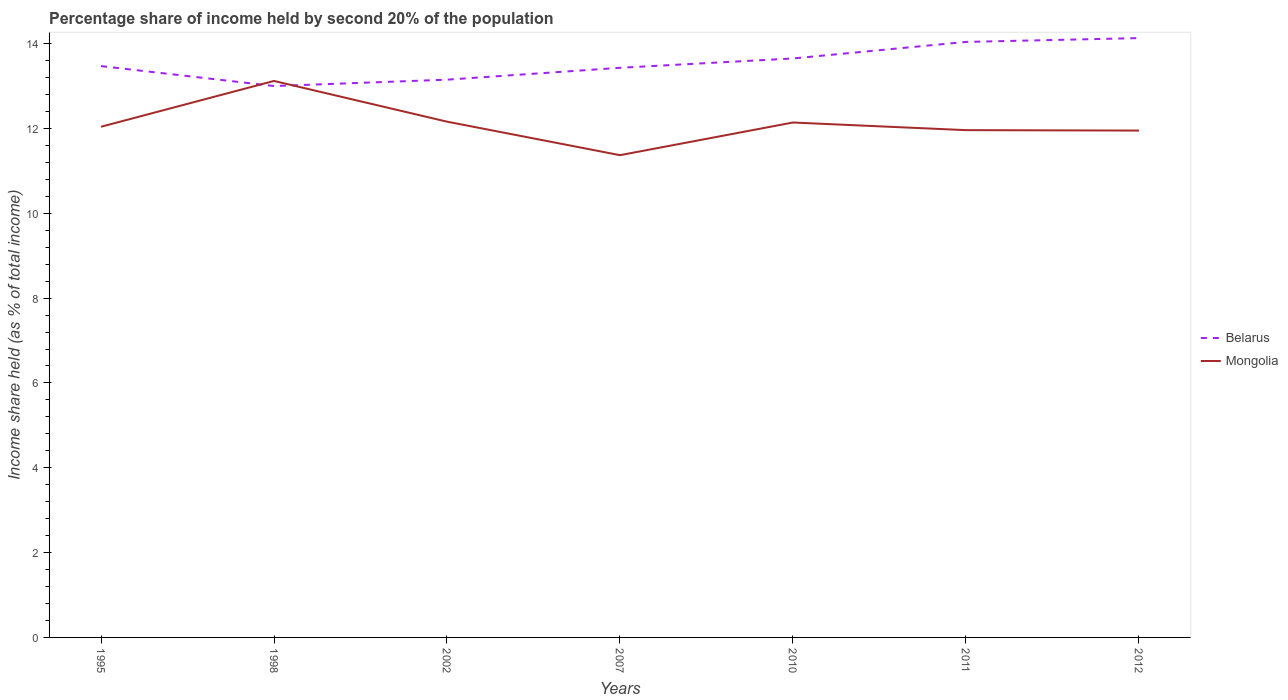Is the number of lines equal to the number of legend labels?
Provide a succinct answer. Yes. Across all years, what is the maximum share of income held by second 20% of the population in Mongolia?
Offer a very short reply. 11.37. What is the total share of income held by second 20% of the population in Belarus in the graph?
Offer a very short reply. -0.15. What is the difference between the highest and the second highest share of income held by second 20% of the population in Mongolia?
Give a very brief answer. 1.75. What is the difference between the highest and the lowest share of income held by second 20% of the population in Mongolia?
Offer a terse response. 3. Is the share of income held by second 20% of the population in Mongolia strictly greater than the share of income held by second 20% of the population in Belarus over the years?
Provide a succinct answer. No. How many years are there in the graph?
Your answer should be very brief. 7. Does the graph contain any zero values?
Your response must be concise. No. Does the graph contain grids?
Make the answer very short. No. What is the title of the graph?
Ensure brevity in your answer.  Percentage share of income held by second 20% of the population. Does "Russian Federation" appear as one of the legend labels in the graph?
Give a very brief answer. No. What is the label or title of the Y-axis?
Offer a terse response. Income share held (as % of total income). What is the Income share held (as % of total income) in Belarus in 1995?
Offer a very short reply. 13.47. What is the Income share held (as % of total income) in Mongolia in 1995?
Make the answer very short. 12.04. What is the Income share held (as % of total income) in Mongolia in 1998?
Keep it short and to the point. 13.12. What is the Income share held (as % of total income) of Belarus in 2002?
Your answer should be compact. 13.15. What is the Income share held (as % of total income) in Mongolia in 2002?
Offer a terse response. 12.16. What is the Income share held (as % of total income) in Belarus in 2007?
Your answer should be compact. 13.43. What is the Income share held (as % of total income) of Mongolia in 2007?
Your response must be concise. 11.37. What is the Income share held (as % of total income) of Belarus in 2010?
Offer a terse response. 13.65. What is the Income share held (as % of total income) in Mongolia in 2010?
Give a very brief answer. 12.14. What is the Income share held (as % of total income) in Belarus in 2011?
Your answer should be compact. 14.04. What is the Income share held (as % of total income) of Mongolia in 2011?
Your answer should be very brief. 11.96. What is the Income share held (as % of total income) in Belarus in 2012?
Your answer should be very brief. 14.13. What is the Income share held (as % of total income) of Mongolia in 2012?
Your response must be concise. 11.95. Across all years, what is the maximum Income share held (as % of total income) in Belarus?
Give a very brief answer. 14.13. Across all years, what is the maximum Income share held (as % of total income) of Mongolia?
Offer a very short reply. 13.12. Across all years, what is the minimum Income share held (as % of total income) in Belarus?
Keep it short and to the point. 13. Across all years, what is the minimum Income share held (as % of total income) in Mongolia?
Your answer should be compact. 11.37. What is the total Income share held (as % of total income) in Belarus in the graph?
Offer a very short reply. 94.87. What is the total Income share held (as % of total income) in Mongolia in the graph?
Give a very brief answer. 84.74. What is the difference between the Income share held (as % of total income) of Belarus in 1995 and that in 1998?
Make the answer very short. 0.47. What is the difference between the Income share held (as % of total income) of Mongolia in 1995 and that in 1998?
Keep it short and to the point. -1.08. What is the difference between the Income share held (as % of total income) in Belarus in 1995 and that in 2002?
Your response must be concise. 0.32. What is the difference between the Income share held (as % of total income) in Mongolia in 1995 and that in 2002?
Ensure brevity in your answer.  -0.12. What is the difference between the Income share held (as % of total income) of Mongolia in 1995 and that in 2007?
Give a very brief answer. 0.67. What is the difference between the Income share held (as % of total income) in Belarus in 1995 and that in 2010?
Your answer should be very brief. -0.18. What is the difference between the Income share held (as % of total income) in Mongolia in 1995 and that in 2010?
Offer a terse response. -0.1. What is the difference between the Income share held (as % of total income) in Belarus in 1995 and that in 2011?
Offer a very short reply. -0.57. What is the difference between the Income share held (as % of total income) in Belarus in 1995 and that in 2012?
Ensure brevity in your answer.  -0.66. What is the difference between the Income share held (as % of total income) in Mongolia in 1995 and that in 2012?
Your answer should be compact. 0.09. What is the difference between the Income share held (as % of total income) in Belarus in 1998 and that in 2002?
Keep it short and to the point. -0.15. What is the difference between the Income share held (as % of total income) in Belarus in 1998 and that in 2007?
Provide a succinct answer. -0.43. What is the difference between the Income share held (as % of total income) in Belarus in 1998 and that in 2010?
Offer a terse response. -0.65. What is the difference between the Income share held (as % of total income) in Belarus in 1998 and that in 2011?
Your response must be concise. -1.04. What is the difference between the Income share held (as % of total income) in Mongolia in 1998 and that in 2011?
Provide a succinct answer. 1.16. What is the difference between the Income share held (as % of total income) in Belarus in 1998 and that in 2012?
Your response must be concise. -1.13. What is the difference between the Income share held (as % of total income) of Mongolia in 1998 and that in 2012?
Keep it short and to the point. 1.17. What is the difference between the Income share held (as % of total income) of Belarus in 2002 and that in 2007?
Ensure brevity in your answer.  -0.28. What is the difference between the Income share held (as % of total income) of Mongolia in 2002 and that in 2007?
Keep it short and to the point. 0.79. What is the difference between the Income share held (as % of total income) of Belarus in 2002 and that in 2010?
Offer a very short reply. -0.5. What is the difference between the Income share held (as % of total income) in Belarus in 2002 and that in 2011?
Provide a succinct answer. -0.89. What is the difference between the Income share held (as % of total income) of Belarus in 2002 and that in 2012?
Your answer should be compact. -0.98. What is the difference between the Income share held (as % of total income) in Mongolia in 2002 and that in 2012?
Give a very brief answer. 0.21. What is the difference between the Income share held (as % of total income) in Belarus in 2007 and that in 2010?
Offer a very short reply. -0.22. What is the difference between the Income share held (as % of total income) of Mongolia in 2007 and that in 2010?
Your answer should be compact. -0.77. What is the difference between the Income share held (as % of total income) in Belarus in 2007 and that in 2011?
Your response must be concise. -0.61. What is the difference between the Income share held (as % of total income) in Mongolia in 2007 and that in 2011?
Offer a terse response. -0.59. What is the difference between the Income share held (as % of total income) of Mongolia in 2007 and that in 2012?
Your response must be concise. -0.58. What is the difference between the Income share held (as % of total income) of Belarus in 2010 and that in 2011?
Your response must be concise. -0.39. What is the difference between the Income share held (as % of total income) of Mongolia in 2010 and that in 2011?
Keep it short and to the point. 0.18. What is the difference between the Income share held (as % of total income) of Belarus in 2010 and that in 2012?
Provide a short and direct response. -0.48. What is the difference between the Income share held (as % of total income) in Mongolia in 2010 and that in 2012?
Offer a very short reply. 0.19. What is the difference between the Income share held (as % of total income) in Belarus in 2011 and that in 2012?
Your answer should be compact. -0.09. What is the difference between the Income share held (as % of total income) of Mongolia in 2011 and that in 2012?
Your answer should be compact. 0.01. What is the difference between the Income share held (as % of total income) in Belarus in 1995 and the Income share held (as % of total income) in Mongolia in 1998?
Make the answer very short. 0.35. What is the difference between the Income share held (as % of total income) in Belarus in 1995 and the Income share held (as % of total income) in Mongolia in 2002?
Your answer should be very brief. 1.31. What is the difference between the Income share held (as % of total income) in Belarus in 1995 and the Income share held (as % of total income) in Mongolia in 2007?
Ensure brevity in your answer.  2.1. What is the difference between the Income share held (as % of total income) of Belarus in 1995 and the Income share held (as % of total income) of Mongolia in 2010?
Offer a very short reply. 1.33. What is the difference between the Income share held (as % of total income) in Belarus in 1995 and the Income share held (as % of total income) in Mongolia in 2011?
Your response must be concise. 1.51. What is the difference between the Income share held (as % of total income) of Belarus in 1995 and the Income share held (as % of total income) of Mongolia in 2012?
Ensure brevity in your answer.  1.52. What is the difference between the Income share held (as % of total income) of Belarus in 1998 and the Income share held (as % of total income) of Mongolia in 2002?
Offer a terse response. 0.84. What is the difference between the Income share held (as % of total income) of Belarus in 1998 and the Income share held (as % of total income) of Mongolia in 2007?
Provide a short and direct response. 1.63. What is the difference between the Income share held (as % of total income) in Belarus in 1998 and the Income share held (as % of total income) in Mongolia in 2010?
Provide a short and direct response. 0.86. What is the difference between the Income share held (as % of total income) of Belarus in 1998 and the Income share held (as % of total income) of Mongolia in 2012?
Your answer should be very brief. 1.05. What is the difference between the Income share held (as % of total income) of Belarus in 2002 and the Income share held (as % of total income) of Mongolia in 2007?
Make the answer very short. 1.78. What is the difference between the Income share held (as % of total income) of Belarus in 2002 and the Income share held (as % of total income) of Mongolia in 2011?
Keep it short and to the point. 1.19. What is the difference between the Income share held (as % of total income) of Belarus in 2007 and the Income share held (as % of total income) of Mongolia in 2010?
Give a very brief answer. 1.29. What is the difference between the Income share held (as % of total income) of Belarus in 2007 and the Income share held (as % of total income) of Mongolia in 2011?
Provide a short and direct response. 1.47. What is the difference between the Income share held (as % of total income) of Belarus in 2007 and the Income share held (as % of total income) of Mongolia in 2012?
Give a very brief answer. 1.48. What is the difference between the Income share held (as % of total income) in Belarus in 2010 and the Income share held (as % of total income) in Mongolia in 2011?
Give a very brief answer. 1.69. What is the difference between the Income share held (as % of total income) in Belarus in 2010 and the Income share held (as % of total income) in Mongolia in 2012?
Make the answer very short. 1.7. What is the difference between the Income share held (as % of total income) of Belarus in 2011 and the Income share held (as % of total income) of Mongolia in 2012?
Provide a short and direct response. 2.09. What is the average Income share held (as % of total income) of Belarus per year?
Provide a short and direct response. 13.55. What is the average Income share held (as % of total income) of Mongolia per year?
Ensure brevity in your answer.  12.11. In the year 1995, what is the difference between the Income share held (as % of total income) of Belarus and Income share held (as % of total income) of Mongolia?
Keep it short and to the point. 1.43. In the year 1998, what is the difference between the Income share held (as % of total income) of Belarus and Income share held (as % of total income) of Mongolia?
Offer a terse response. -0.12. In the year 2002, what is the difference between the Income share held (as % of total income) of Belarus and Income share held (as % of total income) of Mongolia?
Your response must be concise. 0.99. In the year 2007, what is the difference between the Income share held (as % of total income) of Belarus and Income share held (as % of total income) of Mongolia?
Ensure brevity in your answer.  2.06. In the year 2010, what is the difference between the Income share held (as % of total income) of Belarus and Income share held (as % of total income) of Mongolia?
Your response must be concise. 1.51. In the year 2011, what is the difference between the Income share held (as % of total income) of Belarus and Income share held (as % of total income) of Mongolia?
Your answer should be very brief. 2.08. In the year 2012, what is the difference between the Income share held (as % of total income) of Belarus and Income share held (as % of total income) of Mongolia?
Offer a terse response. 2.18. What is the ratio of the Income share held (as % of total income) in Belarus in 1995 to that in 1998?
Offer a terse response. 1.04. What is the ratio of the Income share held (as % of total income) of Mongolia in 1995 to that in 1998?
Ensure brevity in your answer.  0.92. What is the ratio of the Income share held (as % of total income) of Belarus in 1995 to that in 2002?
Keep it short and to the point. 1.02. What is the ratio of the Income share held (as % of total income) in Mongolia in 1995 to that in 2002?
Make the answer very short. 0.99. What is the ratio of the Income share held (as % of total income) of Mongolia in 1995 to that in 2007?
Offer a very short reply. 1.06. What is the ratio of the Income share held (as % of total income) of Belarus in 1995 to that in 2010?
Your answer should be compact. 0.99. What is the ratio of the Income share held (as % of total income) of Belarus in 1995 to that in 2011?
Offer a terse response. 0.96. What is the ratio of the Income share held (as % of total income) of Mongolia in 1995 to that in 2011?
Ensure brevity in your answer.  1.01. What is the ratio of the Income share held (as % of total income) of Belarus in 1995 to that in 2012?
Your response must be concise. 0.95. What is the ratio of the Income share held (as % of total income) of Mongolia in 1995 to that in 2012?
Make the answer very short. 1.01. What is the ratio of the Income share held (as % of total income) in Mongolia in 1998 to that in 2002?
Keep it short and to the point. 1.08. What is the ratio of the Income share held (as % of total income) of Belarus in 1998 to that in 2007?
Give a very brief answer. 0.97. What is the ratio of the Income share held (as % of total income) in Mongolia in 1998 to that in 2007?
Provide a short and direct response. 1.15. What is the ratio of the Income share held (as % of total income) in Belarus in 1998 to that in 2010?
Offer a very short reply. 0.95. What is the ratio of the Income share held (as % of total income) of Mongolia in 1998 to that in 2010?
Make the answer very short. 1.08. What is the ratio of the Income share held (as % of total income) in Belarus in 1998 to that in 2011?
Offer a very short reply. 0.93. What is the ratio of the Income share held (as % of total income) in Mongolia in 1998 to that in 2011?
Your response must be concise. 1.1. What is the ratio of the Income share held (as % of total income) of Belarus in 1998 to that in 2012?
Your answer should be very brief. 0.92. What is the ratio of the Income share held (as % of total income) in Mongolia in 1998 to that in 2012?
Your answer should be very brief. 1.1. What is the ratio of the Income share held (as % of total income) in Belarus in 2002 to that in 2007?
Provide a short and direct response. 0.98. What is the ratio of the Income share held (as % of total income) in Mongolia in 2002 to that in 2007?
Give a very brief answer. 1.07. What is the ratio of the Income share held (as % of total income) in Belarus in 2002 to that in 2010?
Ensure brevity in your answer.  0.96. What is the ratio of the Income share held (as % of total income) in Mongolia in 2002 to that in 2010?
Your answer should be very brief. 1. What is the ratio of the Income share held (as % of total income) of Belarus in 2002 to that in 2011?
Your answer should be very brief. 0.94. What is the ratio of the Income share held (as % of total income) in Mongolia in 2002 to that in 2011?
Give a very brief answer. 1.02. What is the ratio of the Income share held (as % of total income) of Belarus in 2002 to that in 2012?
Keep it short and to the point. 0.93. What is the ratio of the Income share held (as % of total income) in Mongolia in 2002 to that in 2012?
Offer a very short reply. 1.02. What is the ratio of the Income share held (as % of total income) in Belarus in 2007 to that in 2010?
Offer a terse response. 0.98. What is the ratio of the Income share held (as % of total income) in Mongolia in 2007 to that in 2010?
Keep it short and to the point. 0.94. What is the ratio of the Income share held (as % of total income) of Belarus in 2007 to that in 2011?
Offer a very short reply. 0.96. What is the ratio of the Income share held (as % of total income) in Mongolia in 2007 to that in 2011?
Ensure brevity in your answer.  0.95. What is the ratio of the Income share held (as % of total income) of Belarus in 2007 to that in 2012?
Provide a succinct answer. 0.95. What is the ratio of the Income share held (as % of total income) in Mongolia in 2007 to that in 2012?
Ensure brevity in your answer.  0.95. What is the ratio of the Income share held (as % of total income) in Belarus in 2010 to that in 2011?
Provide a succinct answer. 0.97. What is the ratio of the Income share held (as % of total income) of Mongolia in 2010 to that in 2011?
Keep it short and to the point. 1.02. What is the ratio of the Income share held (as % of total income) of Mongolia in 2010 to that in 2012?
Provide a succinct answer. 1.02. What is the ratio of the Income share held (as % of total income) in Mongolia in 2011 to that in 2012?
Provide a succinct answer. 1. What is the difference between the highest and the second highest Income share held (as % of total income) of Belarus?
Offer a very short reply. 0.09. What is the difference between the highest and the lowest Income share held (as % of total income) of Belarus?
Offer a very short reply. 1.13. What is the difference between the highest and the lowest Income share held (as % of total income) in Mongolia?
Offer a very short reply. 1.75. 